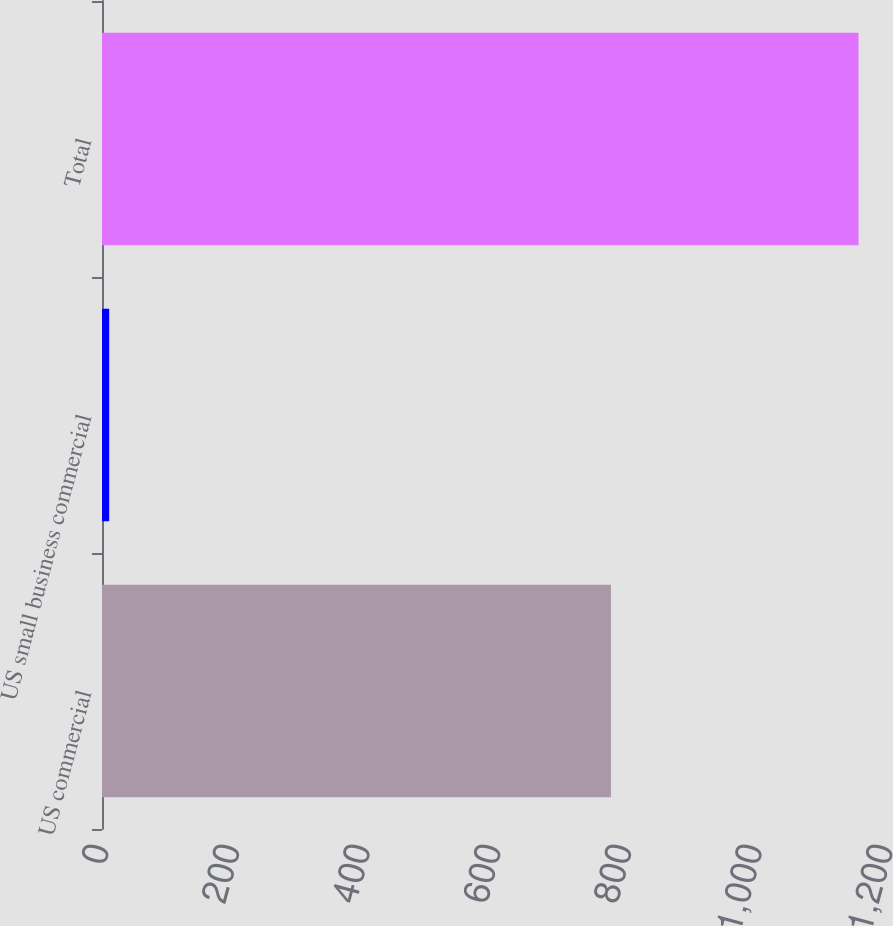<chart> <loc_0><loc_0><loc_500><loc_500><bar_chart><fcel>US commercial<fcel>US small business commercial<fcel>Total<nl><fcel>779<fcel>11<fcel>1158<nl></chart> 